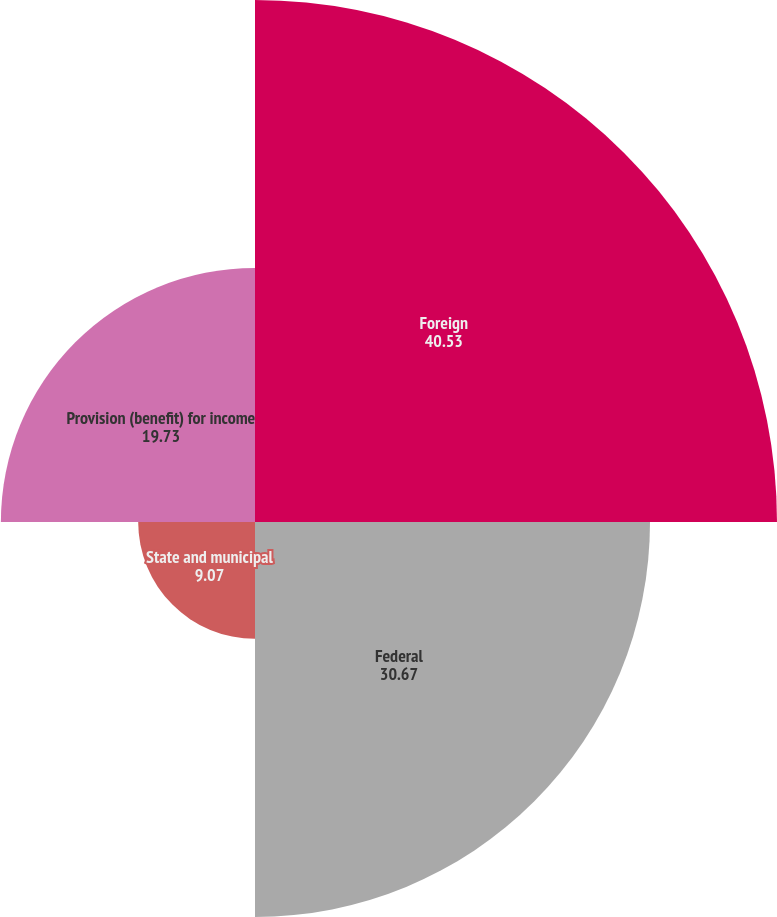Convert chart to OTSL. <chart><loc_0><loc_0><loc_500><loc_500><pie_chart><fcel>Foreign<fcel>Federal<fcel>State and municipal<fcel>Provision (benefit) for income<nl><fcel>40.53%<fcel>30.67%<fcel>9.07%<fcel>19.73%<nl></chart> 